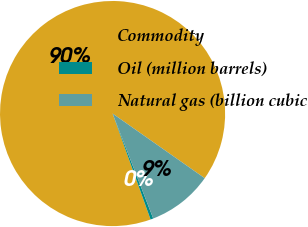Convert chart. <chart><loc_0><loc_0><loc_500><loc_500><pie_chart><fcel>Commodity<fcel>Oil (million barrels)<fcel>Natural gas (billion cubic<nl><fcel>90.21%<fcel>0.4%<fcel>9.38%<nl></chart> 